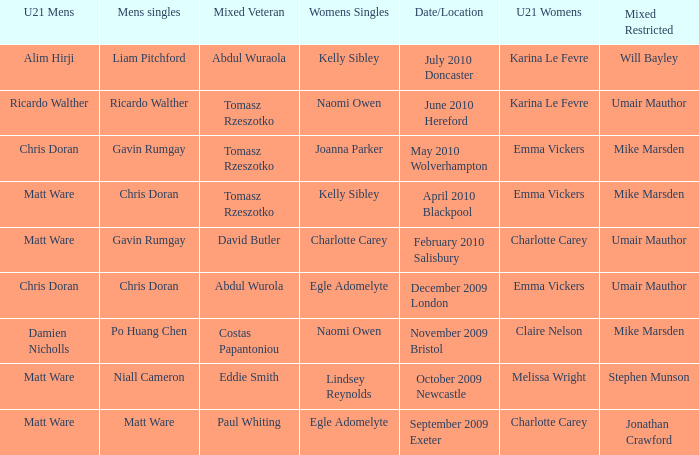When Paul Whiting won the mixed veteran, who won the mixed restricted? Jonathan Crawford. 